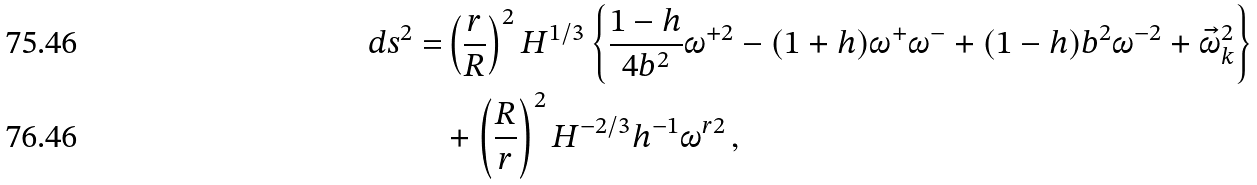Convert formula to latex. <formula><loc_0><loc_0><loc_500><loc_500>d s ^ { 2 } = & \left ( \frac { r } { R } \right ) ^ { 2 } H ^ { 1 / 3 } \left \{ \frac { 1 - h } { 4 b ^ { 2 } } \omega ^ { + 2 } - ( 1 + h ) \omega ^ { + } \omega ^ { - } + ( 1 - h ) b ^ { 2 } \omega ^ { - 2 } + \vec { \omega } _ { k } ^ { 2 } \right \} \\ & + \left ( \frac { R } { r } \right ) ^ { 2 } H ^ { - 2 / 3 } h ^ { - 1 } \omega ^ { r 2 } \, ,</formula> 